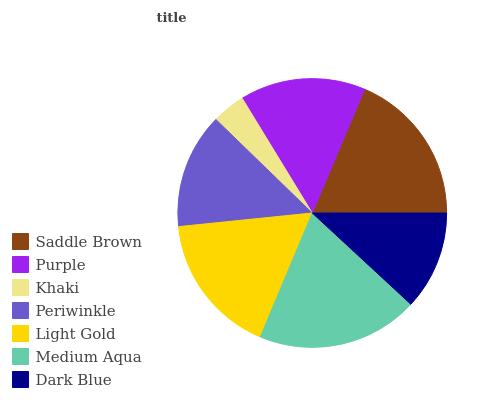Is Khaki the minimum?
Answer yes or no. Yes. Is Medium Aqua the maximum?
Answer yes or no. Yes. Is Purple the minimum?
Answer yes or no. No. Is Purple the maximum?
Answer yes or no. No. Is Saddle Brown greater than Purple?
Answer yes or no. Yes. Is Purple less than Saddle Brown?
Answer yes or no. Yes. Is Purple greater than Saddle Brown?
Answer yes or no. No. Is Saddle Brown less than Purple?
Answer yes or no. No. Is Purple the high median?
Answer yes or no. Yes. Is Purple the low median?
Answer yes or no. Yes. Is Medium Aqua the high median?
Answer yes or no. No. Is Dark Blue the low median?
Answer yes or no. No. 